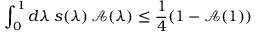Convert formula to latex. <formula><loc_0><loc_0><loc_500><loc_500>\int _ { 0 } ^ { 1 } d \lambda \, s ( \lambda ) \, \mathcal { A } ( \lambda ) \leq \frac { 1 } { 4 } ( 1 - \mathcal { A } ( 1 ) )</formula> 